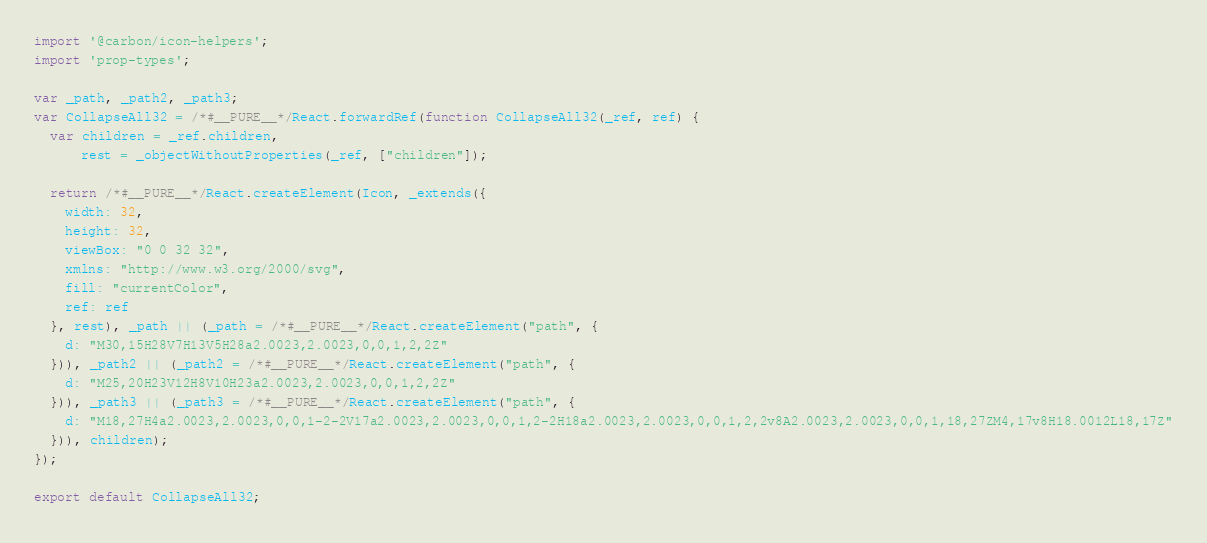Convert code to text. <code><loc_0><loc_0><loc_500><loc_500><_JavaScript_>import '@carbon/icon-helpers';
import 'prop-types';

var _path, _path2, _path3;
var CollapseAll32 = /*#__PURE__*/React.forwardRef(function CollapseAll32(_ref, ref) {
  var children = _ref.children,
      rest = _objectWithoutProperties(_ref, ["children"]);

  return /*#__PURE__*/React.createElement(Icon, _extends({
    width: 32,
    height: 32,
    viewBox: "0 0 32 32",
    xmlns: "http://www.w3.org/2000/svg",
    fill: "currentColor",
    ref: ref
  }, rest), _path || (_path = /*#__PURE__*/React.createElement("path", {
    d: "M30,15H28V7H13V5H28a2.0023,2.0023,0,0,1,2,2Z"
  })), _path2 || (_path2 = /*#__PURE__*/React.createElement("path", {
    d: "M25,20H23V12H8V10H23a2.0023,2.0023,0,0,1,2,2Z"
  })), _path3 || (_path3 = /*#__PURE__*/React.createElement("path", {
    d: "M18,27H4a2.0023,2.0023,0,0,1-2-2V17a2.0023,2.0023,0,0,1,2-2H18a2.0023,2.0023,0,0,1,2,2v8A2.0023,2.0023,0,0,1,18,27ZM4,17v8H18.0012L18,17Z"
  })), children);
});

export default CollapseAll32;
</code> 